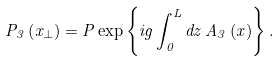Convert formula to latex. <formula><loc_0><loc_0><loc_500><loc_500>P _ { 3 } \left ( x _ { \perp } \right ) = P \exp \left \{ i g \int _ { 0 } ^ { L } d z \, A _ { 3 } \left ( x \right ) \right \} .</formula> 